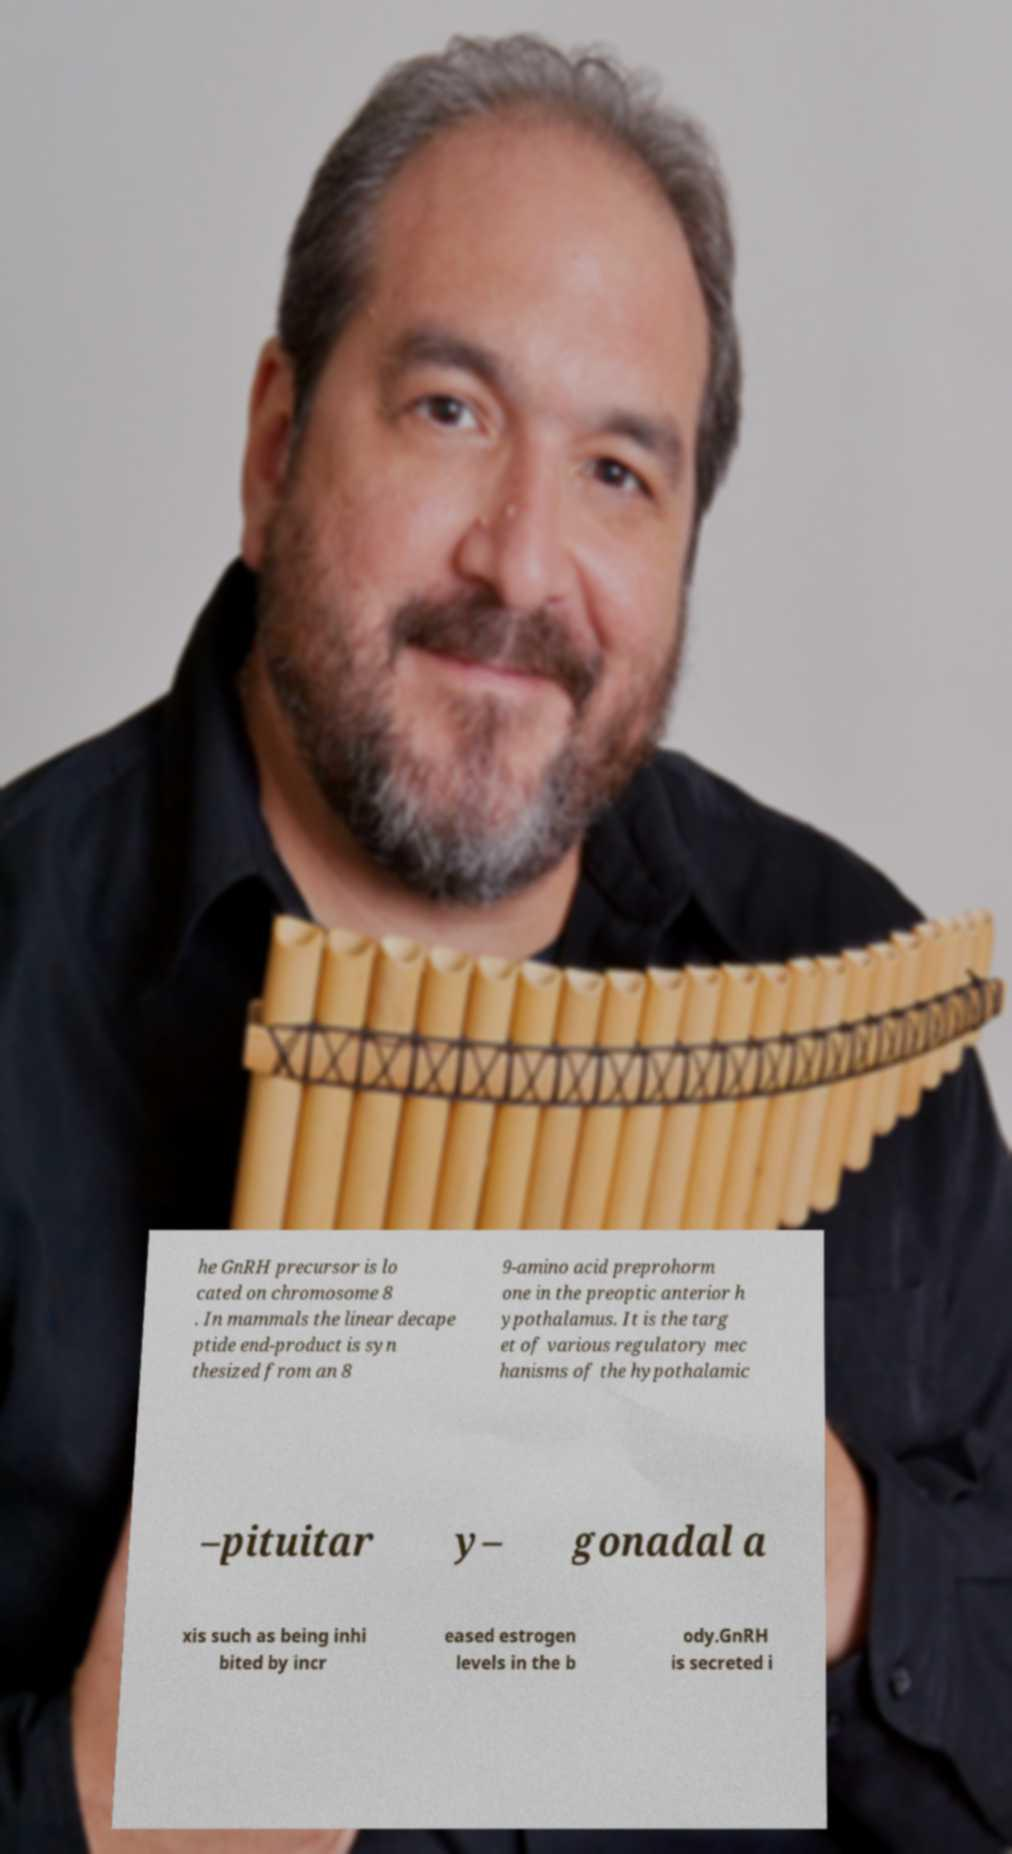What messages or text are displayed in this image? I need them in a readable, typed format. he GnRH precursor is lo cated on chromosome 8 . In mammals the linear decape ptide end-product is syn thesized from an 8 9-amino acid preprohorm one in the preoptic anterior h ypothalamus. It is the targ et of various regulatory mec hanisms of the hypothalamic –pituitar y– gonadal a xis such as being inhi bited by incr eased estrogen levels in the b ody.GnRH is secreted i 